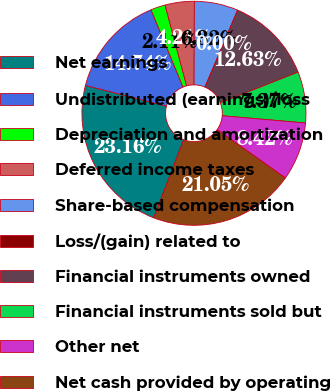Convert chart. <chart><loc_0><loc_0><loc_500><loc_500><pie_chart><fcel>Net earnings<fcel>Undistributed (earnings)/loss<fcel>Depreciation and amortization<fcel>Deferred income taxes<fcel>Share-based compensation<fcel>Loss/(gain) related to<fcel>Financial instruments owned<fcel>Financial instruments sold but<fcel>Other net<fcel>Net cash provided by operating<nl><fcel>23.16%<fcel>14.74%<fcel>2.11%<fcel>4.21%<fcel>6.32%<fcel>0.0%<fcel>12.63%<fcel>7.37%<fcel>8.42%<fcel>21.05%<nl></chart> 